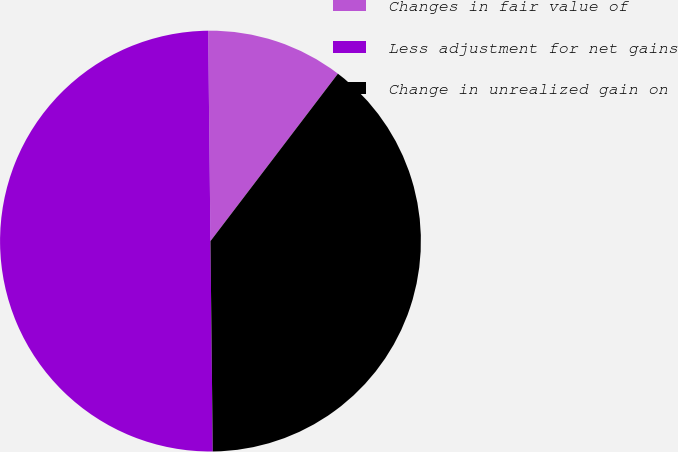<chart> <loc_0><loc_0><loc_500><loc_500><pie_chart><fcel>Changes in fair value of<fcel>Less adjustment for net gains<fcel>Change in unrealized gain on<nl><fcel>10.53%<fcel>50.0%<fcel>39.47%<nl></chart> 